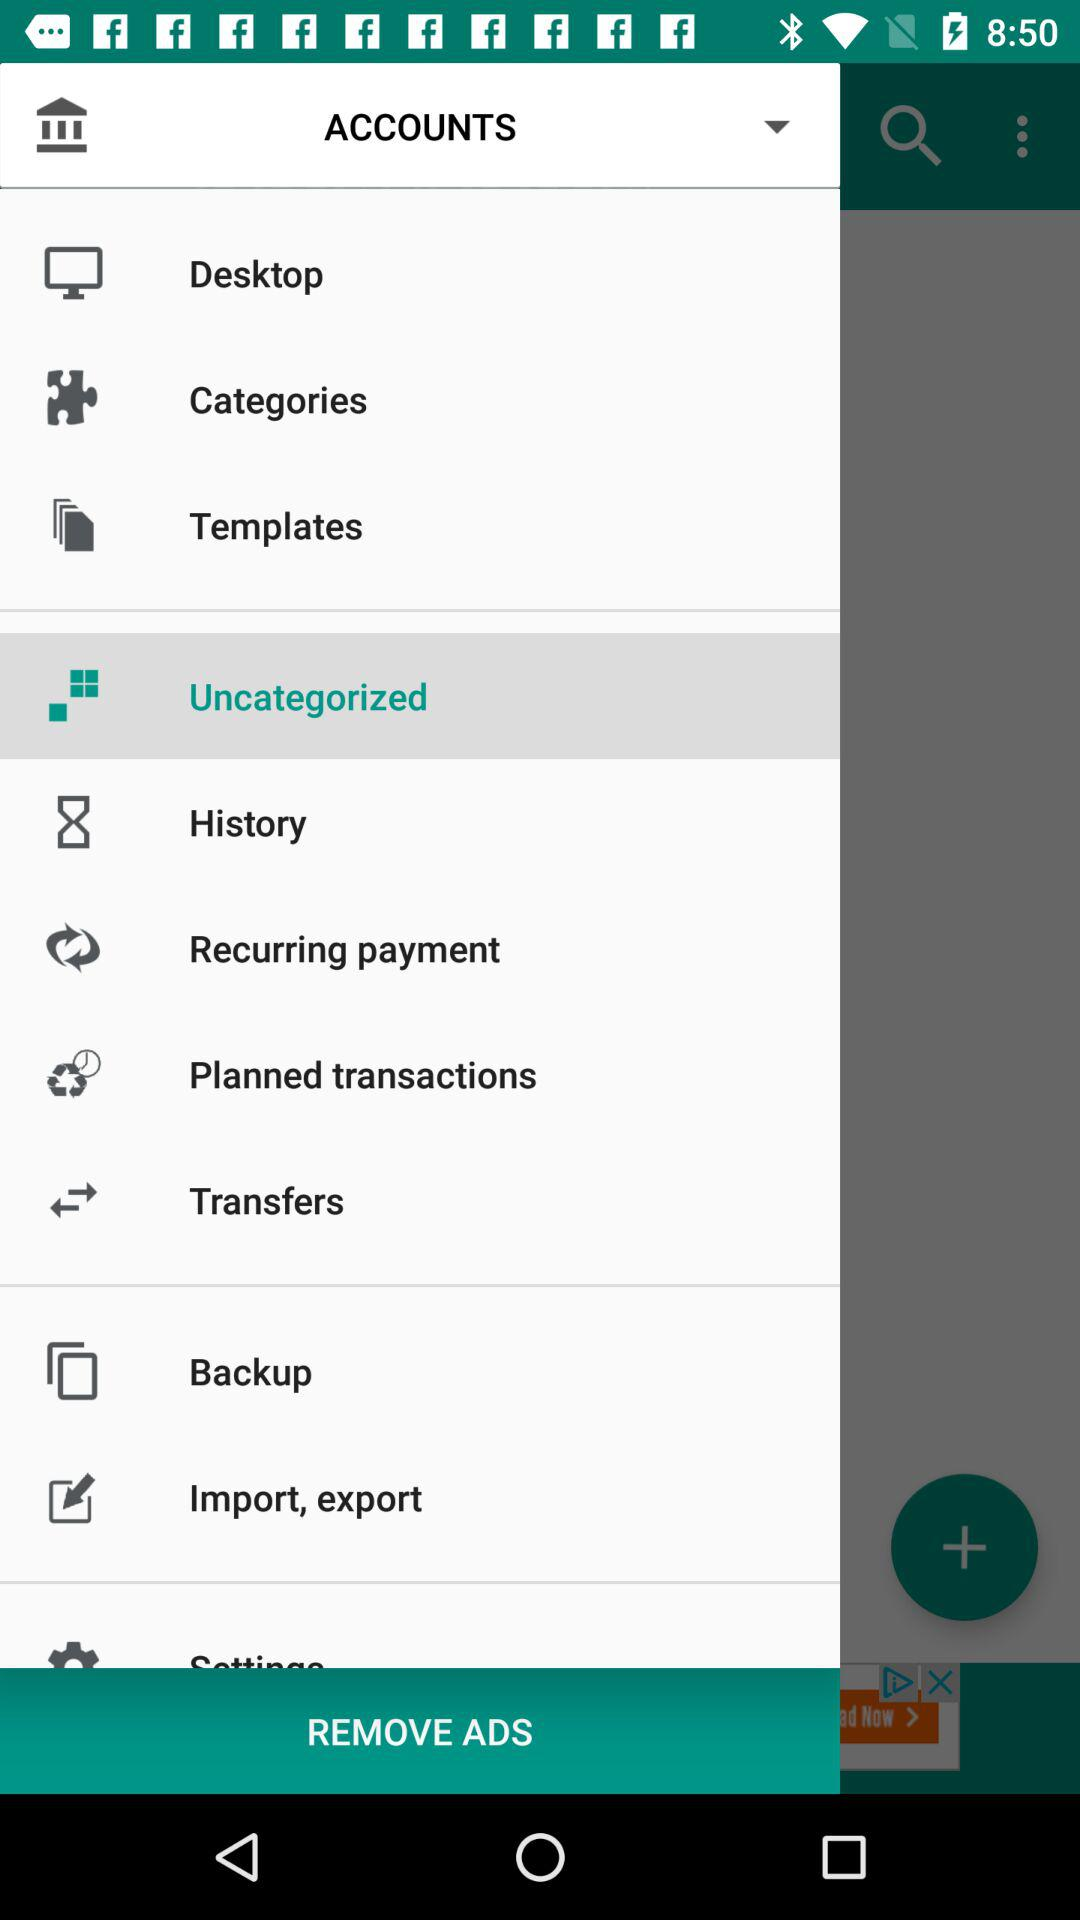Which option is selected? The selected option is "Uncategorized". 